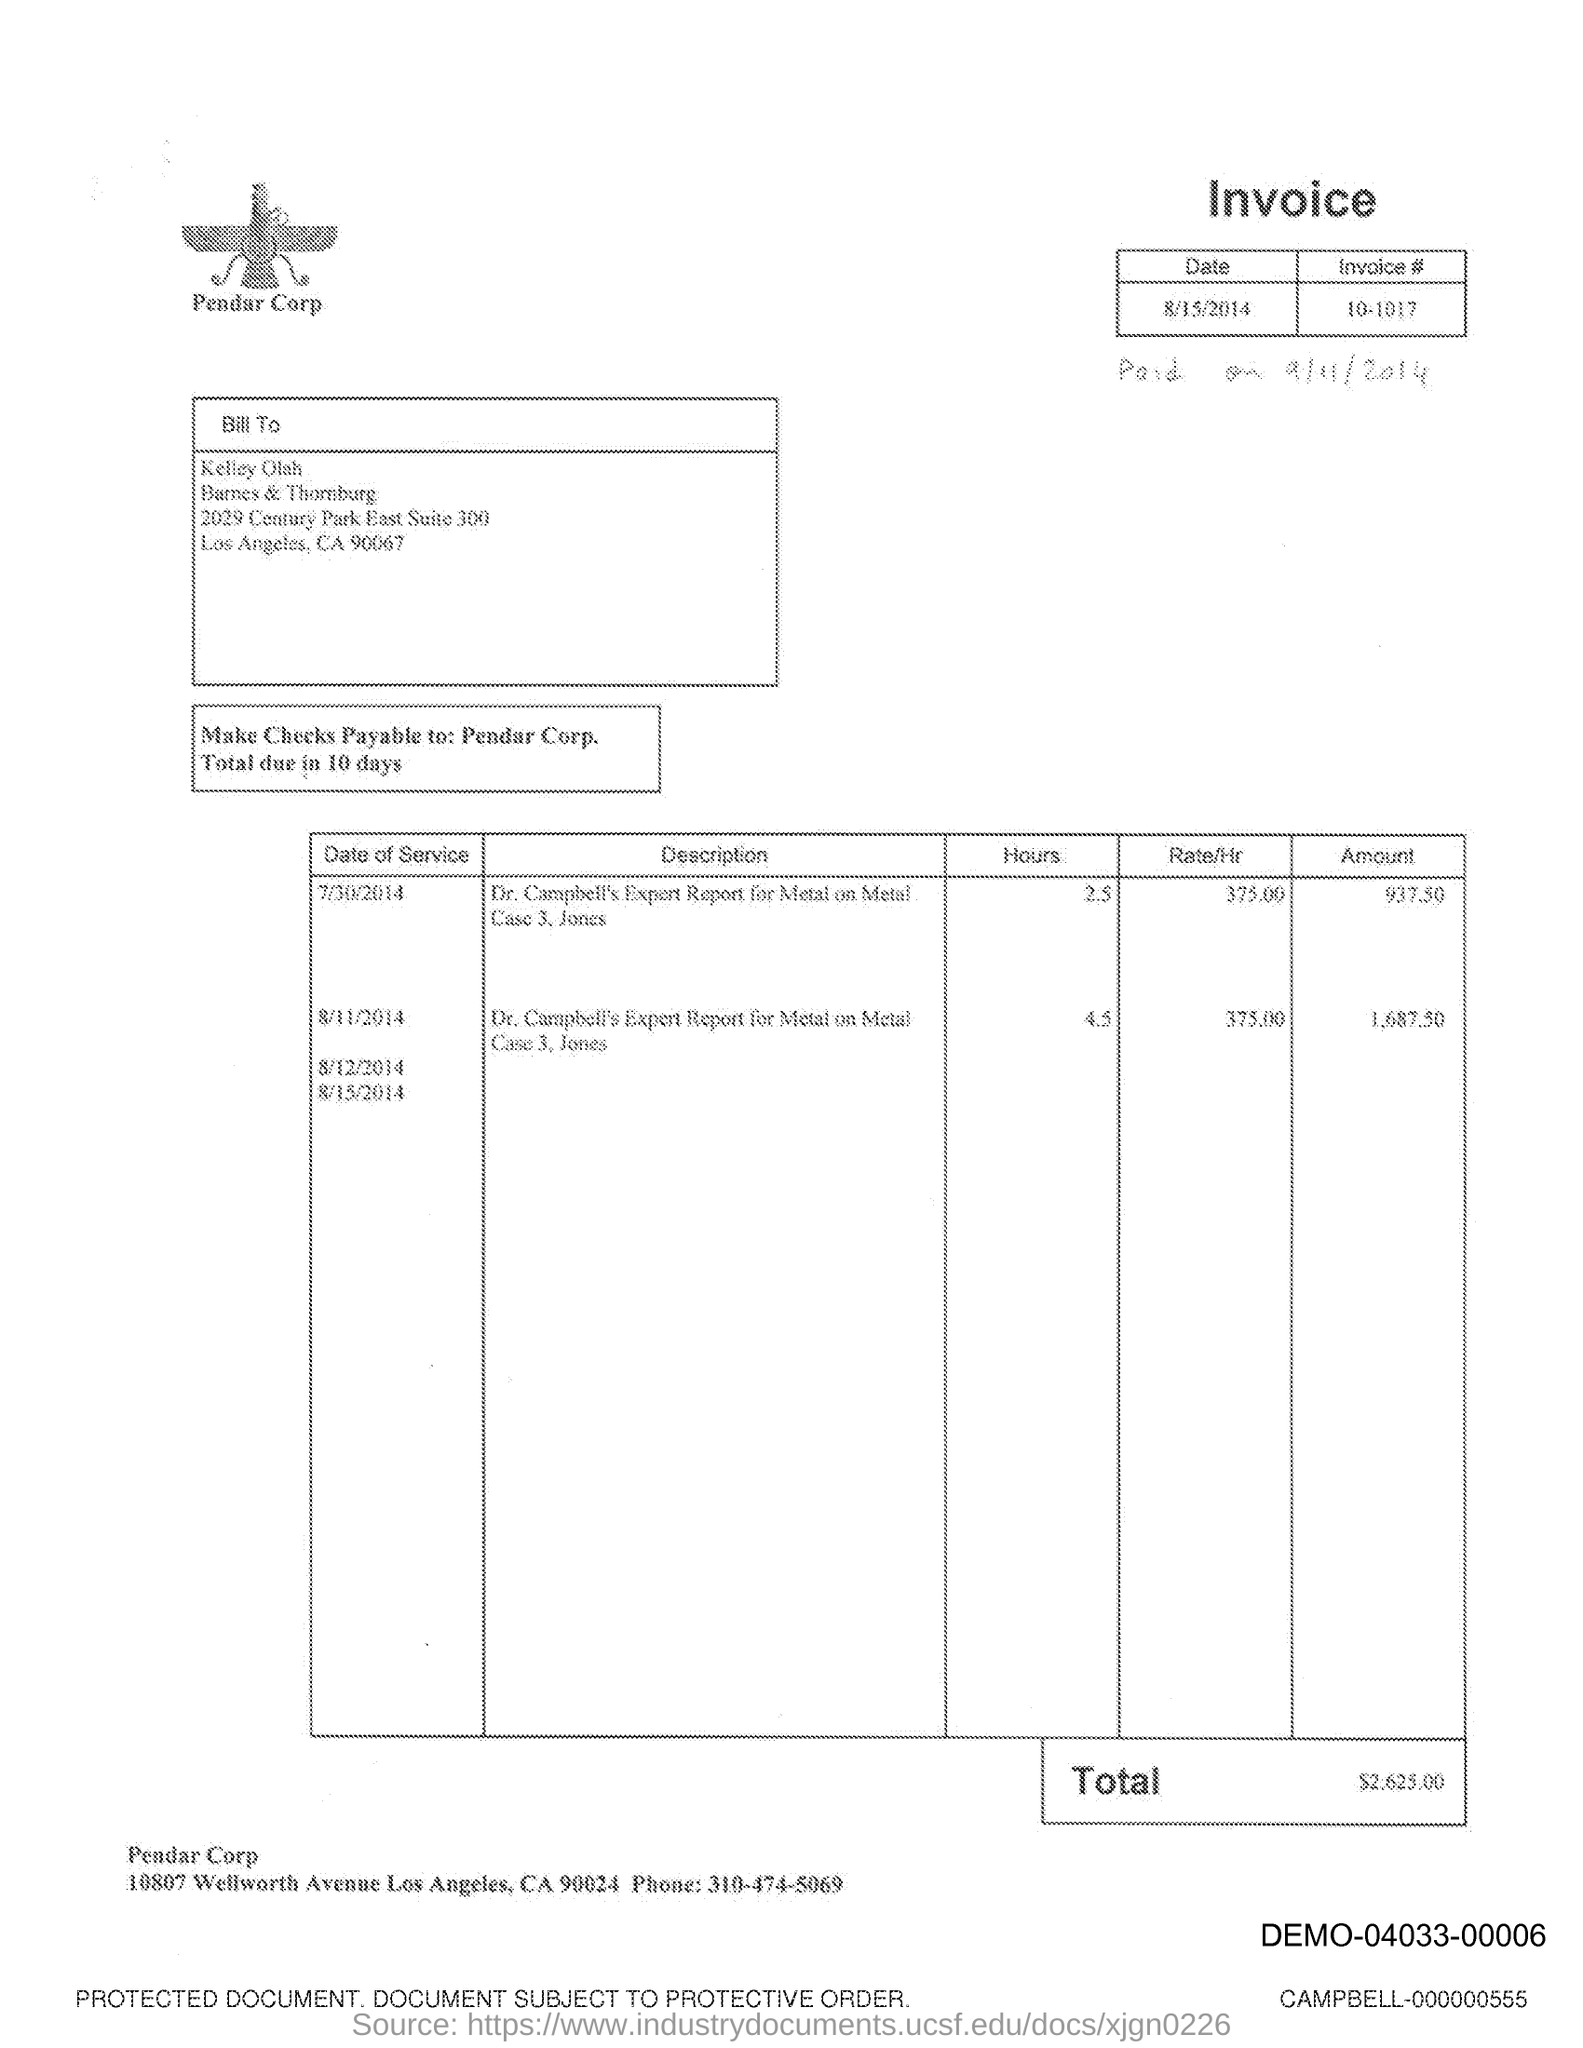What is the date of the invoice?
Your response must be concise. 8/15/2014. What is the invoice #?
Your answer should be compact. 10-1017. To whom is it billed?
Provide a succinct answer. Kelley Olah. What is the total invoice amout?
Offer a very short reply. $2625.00. What is the phone number mentioned?
Offer a very short reply. 310-474-5069. 